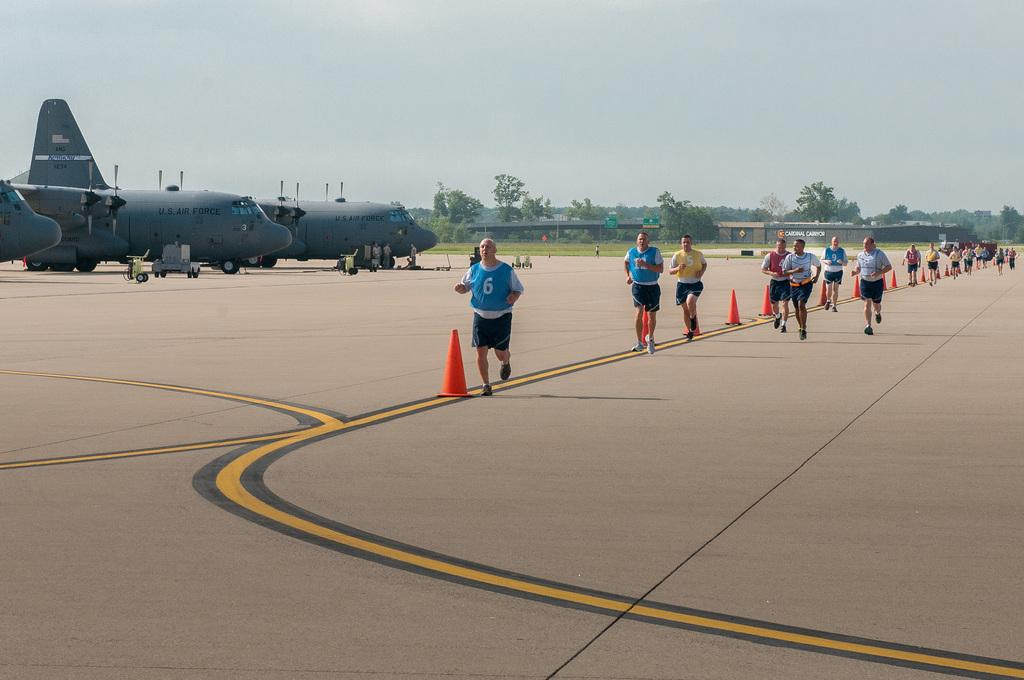Provide a one-sentence caption for the provided image. People run on the runway that sits planes labeled as US Air Force. 